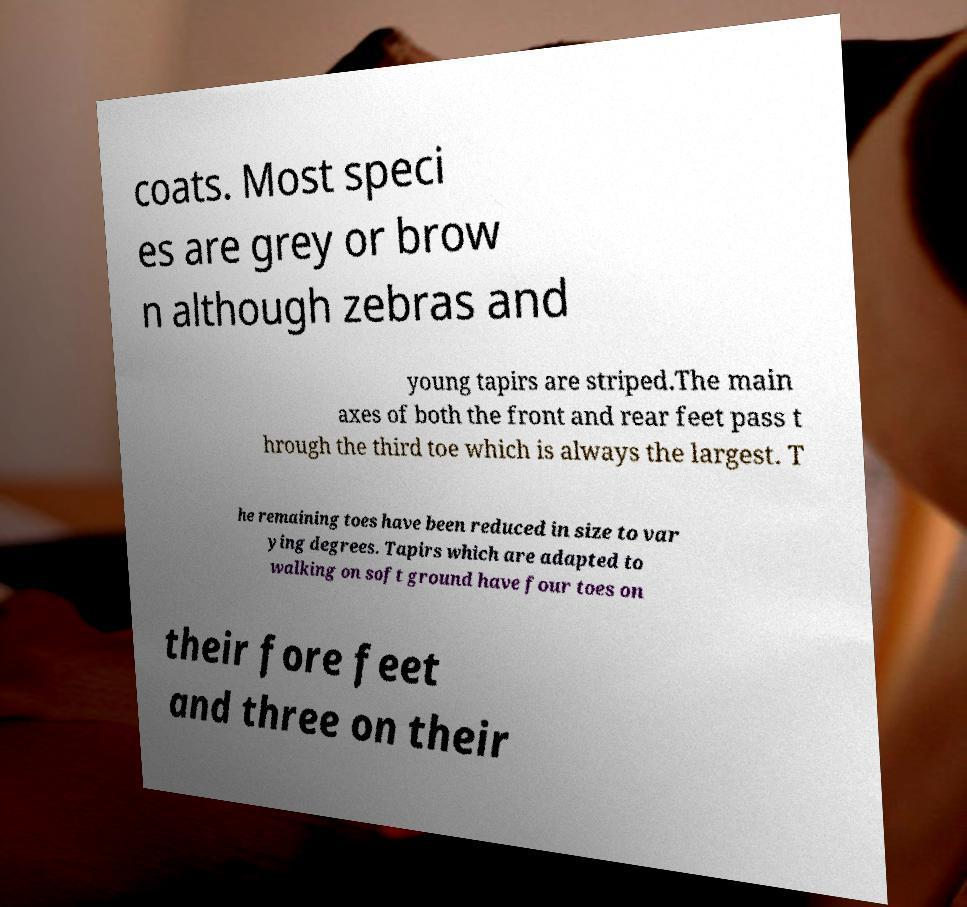Can you read and provide the text displayed in the image?This photo seems to have some interesting text. Can you extract and type it out for me? coats. Most speci es are grey or brow n although zebras and young tapirs are striped.The main axes of both the front and rear feet pass t hrough the third toe which is always the largest. T he remaining toes have been reduced in size to var ying degrees. Tapirs which are adapted to walking on soft ground have four toes on their fore feet and three on their 